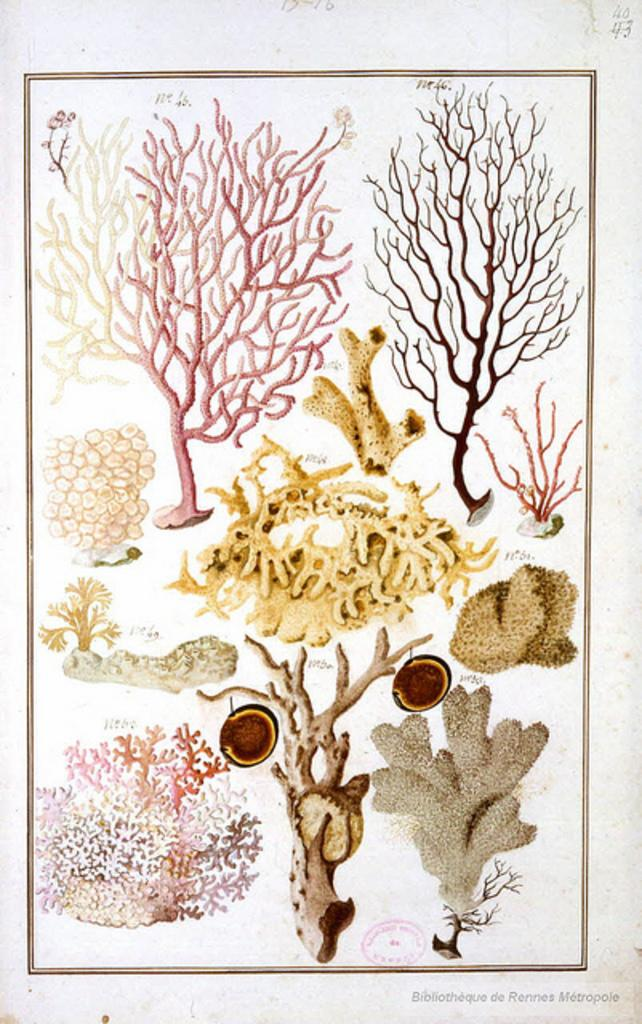What types of objects are present in the image? The image contains different types of trees depicted on a paper. What is the color of the paper in the image? The paper is white in color. What feature can be seen around the edges of the paper? There is a border on the paper. What color is the background of the image? The background of the image is white. What type of pen is used to draw the trees in the image? There is no pen visible in the image, and it is not mentioned that the trees were drawn with a pen. 